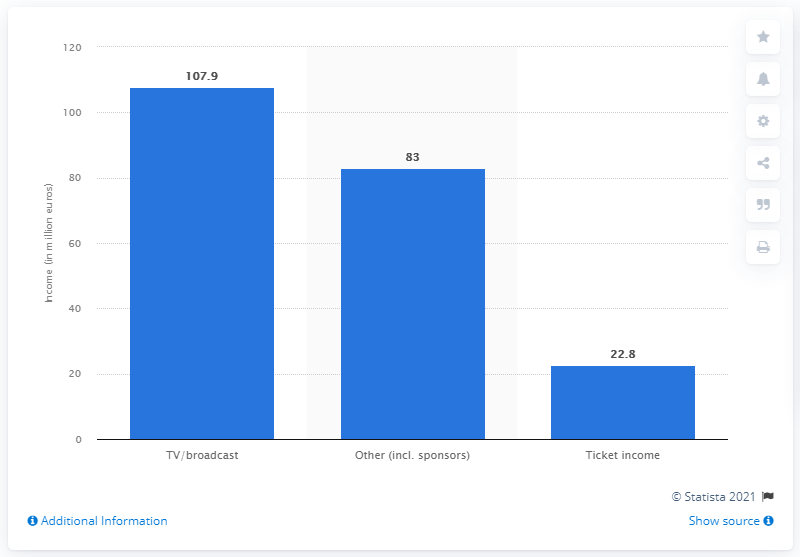Highlight a few significant elements in this photo. In the 2011/12 season, the total income from ticketing for all 20 clubs was 22.8 million pounds. 